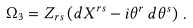<formula> <loc_0><loc_0><loc_500><loc_500>\Omega _ { 3 } = Z _ { r s } \left ( d X ^ { r s } - i \theta ^ { r } \, d \theta ^ { s } \right ) \, .</formula> 